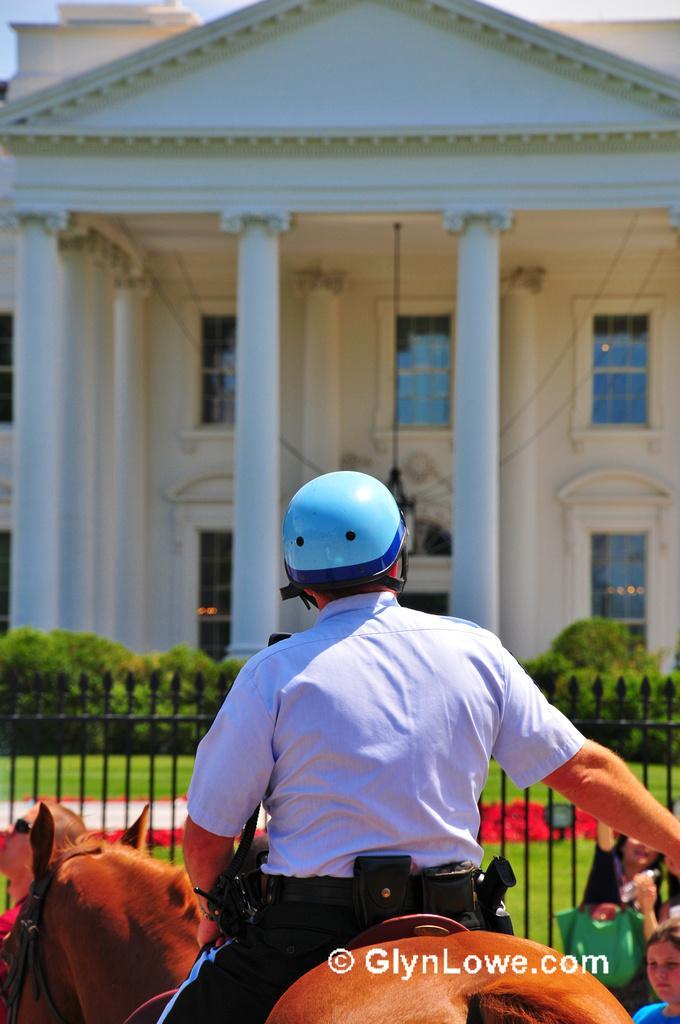Can you describe this image briefly? This man is sitting on a horse wore blue helmet. Fence is in black color. Far there are plants and grass. A white house building with white pillar and windows. 